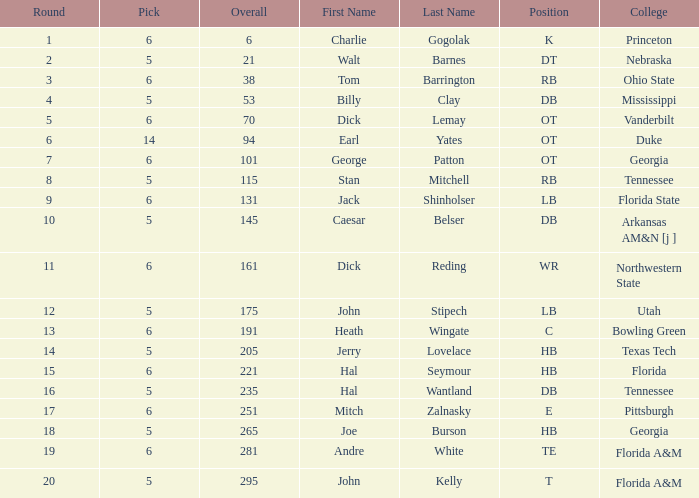What is the highest Pick, when Round is greater than 15, and when College is "Tennessee"? 5.0. 